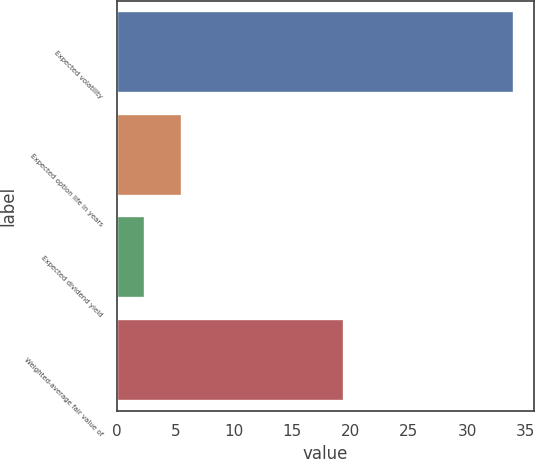Convert chart. <chart><loc_0><loc_0><loc_500><loc_500><bar_chart><fcel>Expected volatility<fcel>Expected option life in years<fcel>Expected dividend yield<fcel>Weighted-average fair value of<nl><fcel>34<fcel>5.56<fcel>2.4<fcel>19.46<nl></chart> 